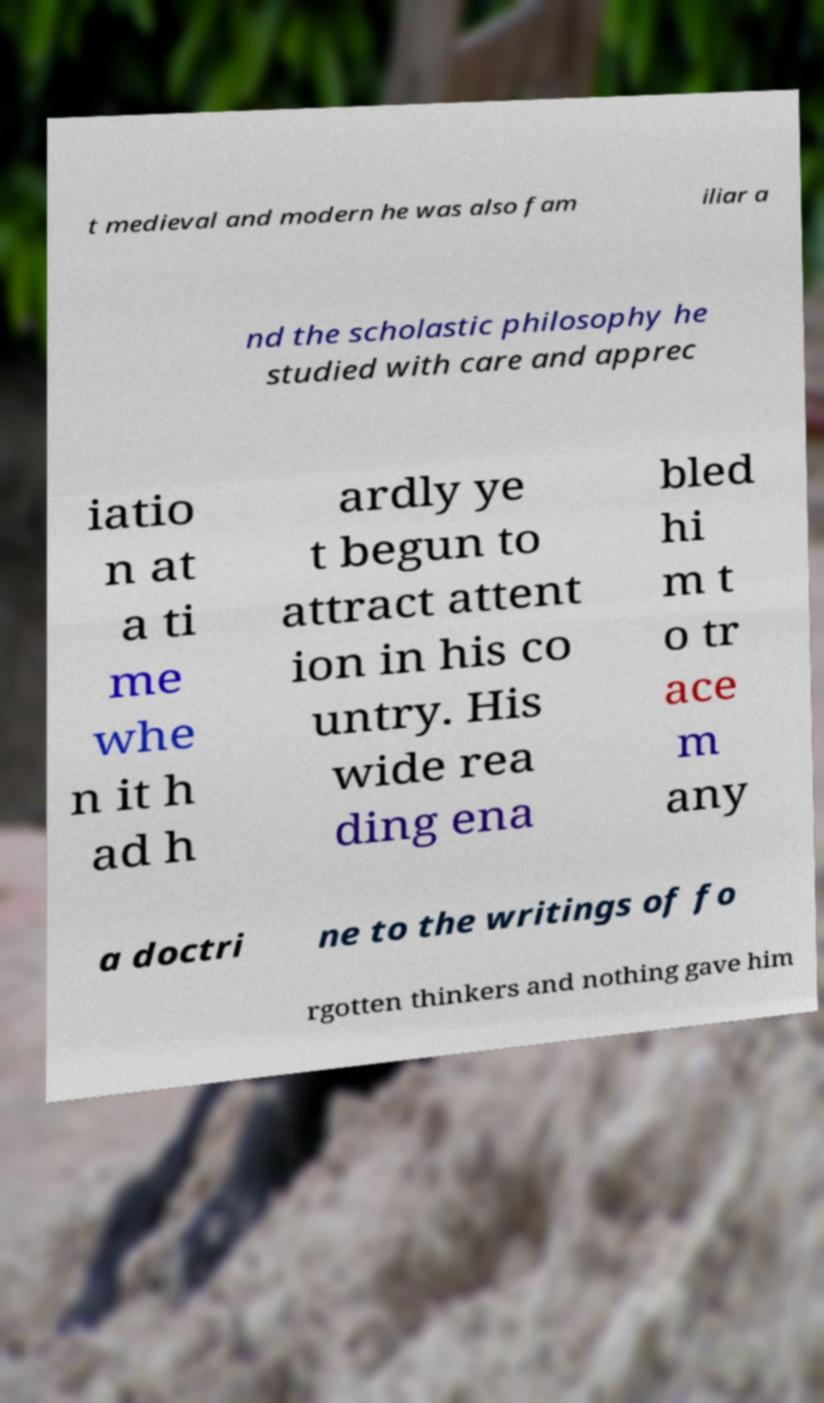There's text embedded in this image that I need extracted. Can you transcribe it verbatim? t medieval and modern he was also fam iliar a nd the scholastic philosophy he studied with care and apprec iatio n at a ti me whe n it h ad h ardly ye t begun to attract attent ion in his co untry. His wide rea ding ena bled hi m t o tr ace m any a doctri ne to the writings of fo rgotten thinkers and nothing gave him 